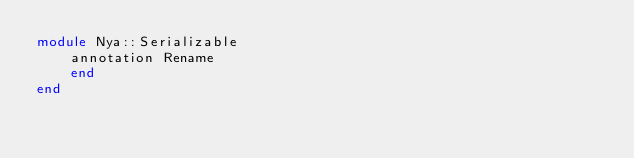<code> <loc_0><loc_0><loc_500><loc_500><_Crystal_>module Nya::Serializable
    annotation Rename
    end
end</code> 